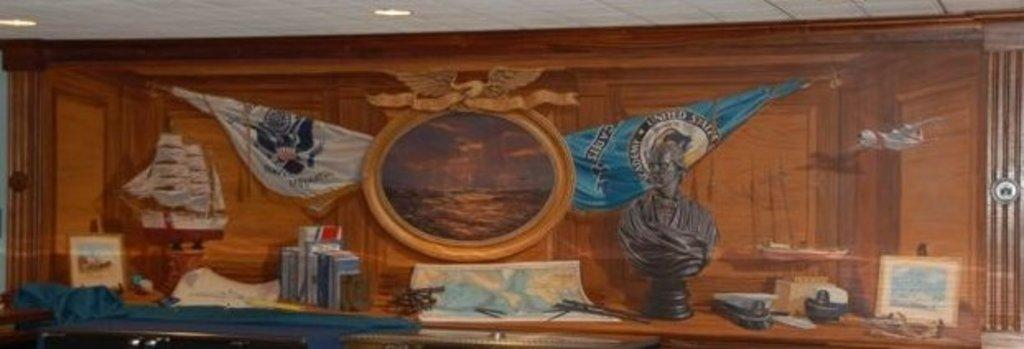What is the main structure in the image? There is a rack in the image. image. What type of items can be seen on the rack? A painting, two flags, an artificial ship, photo frames, books, and a sculpture are placed on the rack. Are there any additional objects on the rack? Yes, there are additional objects on the rack. What is visible on the top of the rack? Lights are visible on the top of the rack. How does the sculpture quiver in the image? The sculpture does not quiver in the image; it is stationary on the rack. 